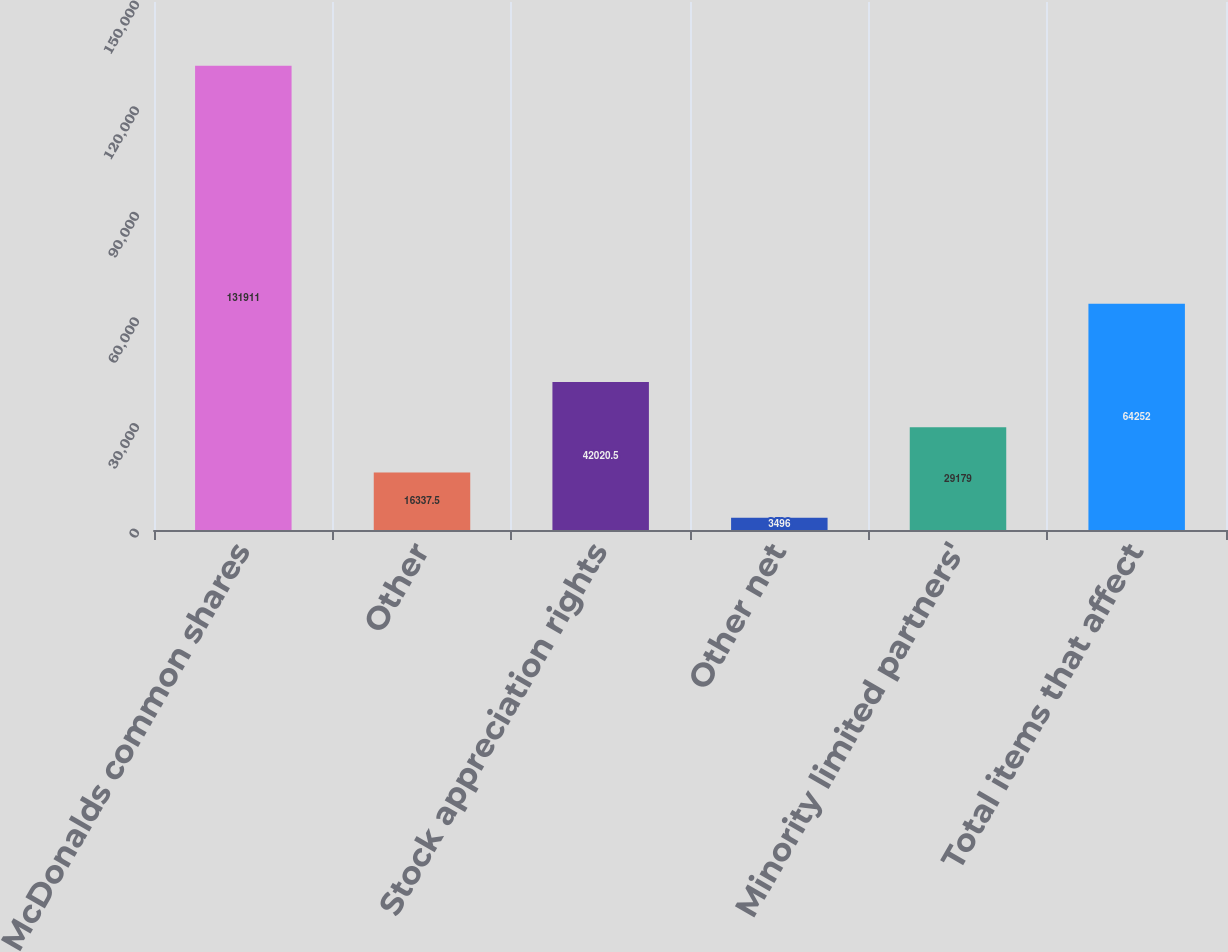Convert chart. <chart><loc_0><loc_0><loc_500><loc_500><bar_chart><fcel>McDonalds common shares<fcel>Other<fcel>Stock appreciation rights<fcel>Other net<fcel>Minority limited partners'<fcel>Total items that affect<nl><fcel>131911<fcel>16337.5<fcel>42020.5<fcel>3496<fcel>29179<fcel>64252<nl></chart> 